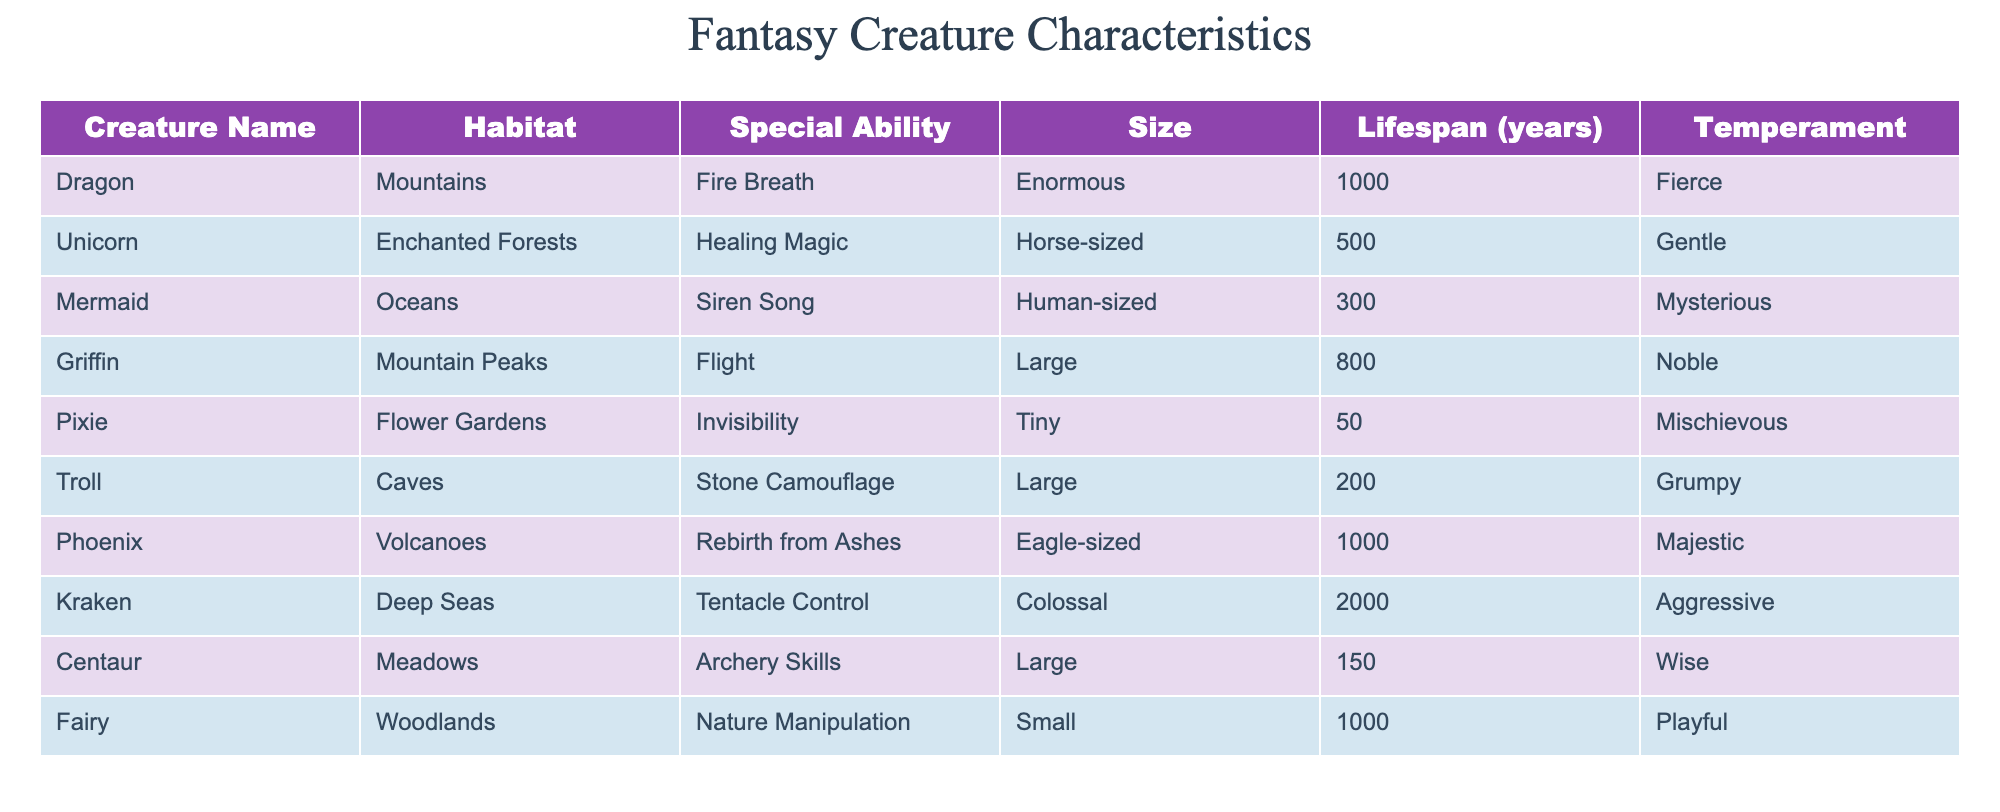What is the special ability of a Griffin? By referencing the table, under the 'Special Ability' column for the 'Griffin' row, we find that its special ability is 'Flight.'
Answer: Flight Which creatures have a lifespan longer than 500 years? I look at the 'Lifespan' column and check each creature's lifespan. The Unicorn (500), Dragon (1000), Phoenix (1000), and Fairy (1000) all have lifespans that meet the criteria. Therefore, the creatures with longer lifespans are Dragon, Phoenix, and Fairy.
Answer: Dragon, Phoenix, Fairy Is a Mermaid known for having healing magic? Referring to the 'Special Ability' column for the 'Mermaid' row, the special ability stated is 'Siren Song,' not healing magic. Therefore, it is false that a Mermaid has healing magic.
Answer: No What is the average size of the creatures listed in the table? To find the average size, we classify the sizes. Assign numeric values: Enormous (5), Horse-sized (4), Human-sized (3), Large (4), Tiny (1), Grumpy (4), Colossal (6), Eagle-sized (3), Large (4), Small (2). The sizes are represented as: 5, 4, 3, 4, 1, 4, 6, 3, 4, 2. The sum is 36 and there are 10 creatures, so 36/10 = 3.6, which we can interpret generally as Medium.
Answer: Medium Which creature has the most aggressive temperament? I review the 'Temperament' column to locate the creatures labeled as aggressive. The table indicates that the Kraken is the creature identified as 'Aggressive.'
Answer: Kraken What is the combined lifespan of a Unicorn and a Pixie? The lifespan of the Unicorn is 500 years and the Pixie is 50 years. To find the combined lifespan, I add these values: 500 + 50 = 550 years.
Answer: 550 Which creatures are known for being Noble and Wise? I need to check the 'Temperament' column and identify the 'Noble' and 'Wise' creatures. The Griffin is Noble while the Centaur is Wise, leading to Griffin and Centaur as the answer.
Answer: Griffin, Centaur Is the total count of creatures that have flight and stone camouflage greater than four? The table confirms that only Griffin has flight and Troll has stone camouflage, providing a total of 2 creatures. As 2 is not greater than 4, the answer is false.
Answer: No What is the smallest creature in the table? I refer to the 'Size' column and see that the Pixie is classified as 'Tiny,' making it the smallest creature listed.
Answer: Pixie 